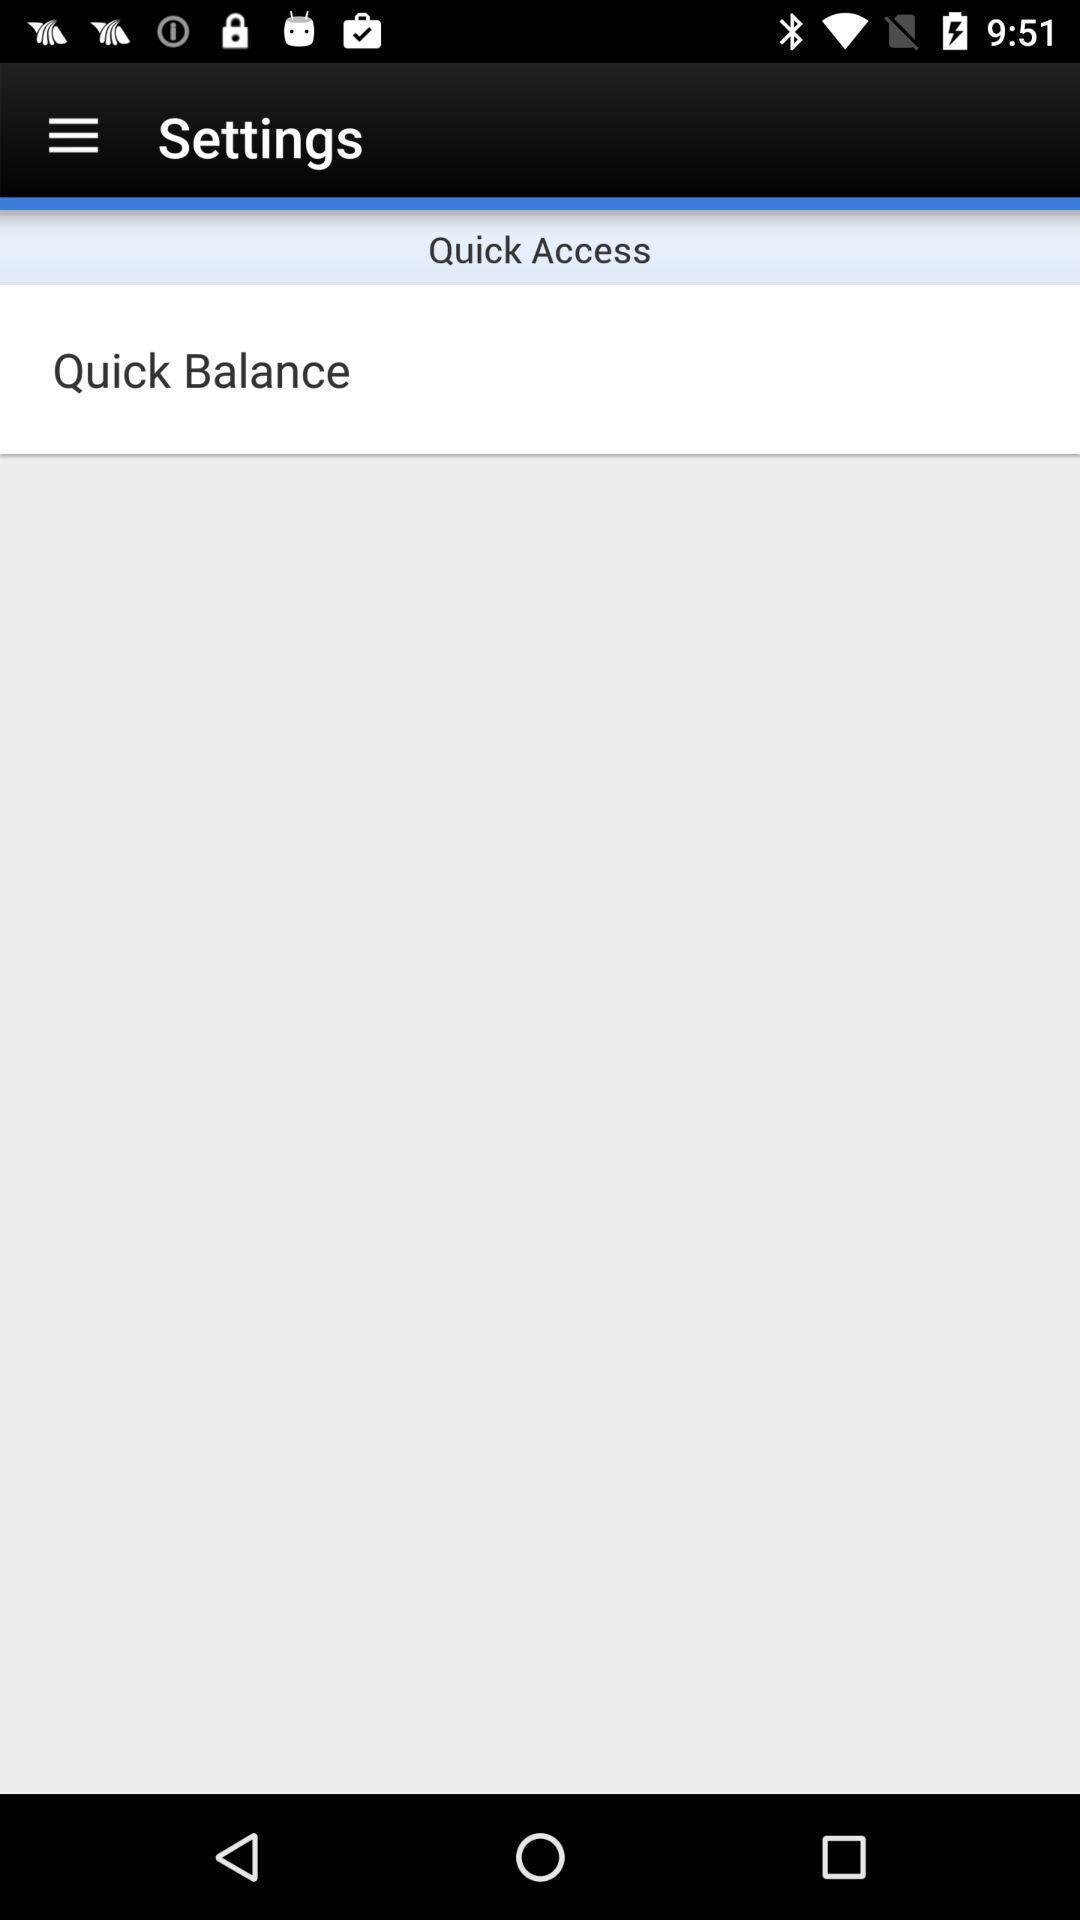Tell me what you see in this picture. Settings page. 